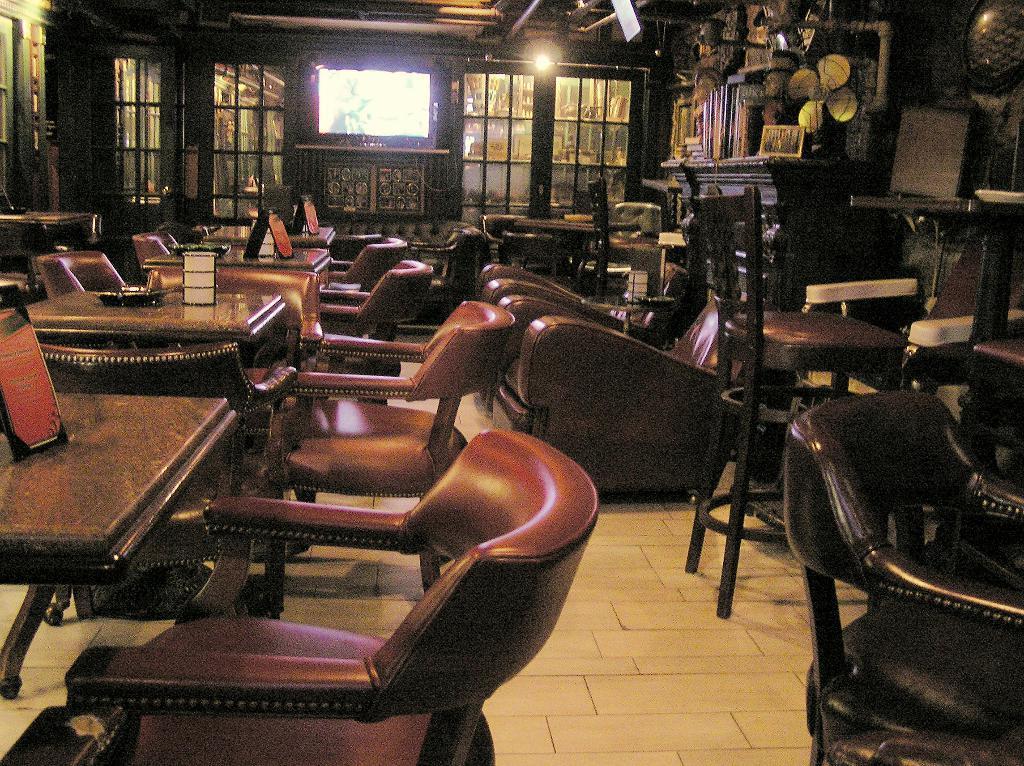Please provide a concise description of this image. This image seems to be clicked in a restaurant, there are tables and chairs around the floor, in the back there is a tv in the middle of the wall with doors on either side of it, on the right side there is a table with books and somethings over it. 